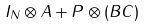Convert formula to latex. <formula><loc_0><loc_0><loc_500><loc_500>I _ { N } \otimes A + P \otimes ( B C )</formula> 